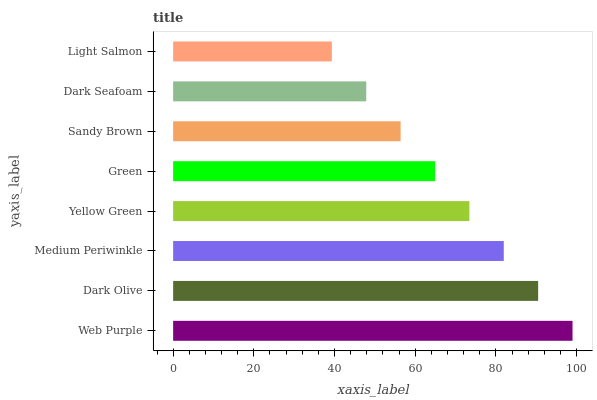Is Light Salmon the minimum?
Answer yes or no. Yes. Is Web Purple the maximum?
Answer yes or no. Yes. Is Dark Olive the minimum?
Answer yes or no. No. Is Dark Olive the maximum?
Answer yes or no. No. Is Web Purple greater than Dark Olive?
Answer yes or no. Yes. Is Dark Olive less than Web Purple?
Answer yes or no. Yes. Is Dark Olive greater than Web Purple?
Answer yes or no. No. Is Web Purple less than Dark Olive?
Answer yes or no. No. Is Yellow Green the high median?
Answer yes or no. Yes. Is Green the low median?
Answer yes or no. Yes. Is Medium Periwinkle the high median?
Answer yes or no. No. Is Sandy Brown the low median?
Answer yes or no. No. 